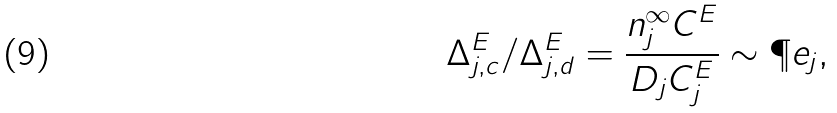<formula> <loc_0><loc_0><loc_500><loc_500>\Delta _ { j , c } ^ { E } / \Delta _ { j , d } ^ { E } = \frac { n _ { j } ^ { \infty } C ^ { E } } { D _ { j } C _ { j } ^ { E } } \sim \P e _ { j } ,</formula> 